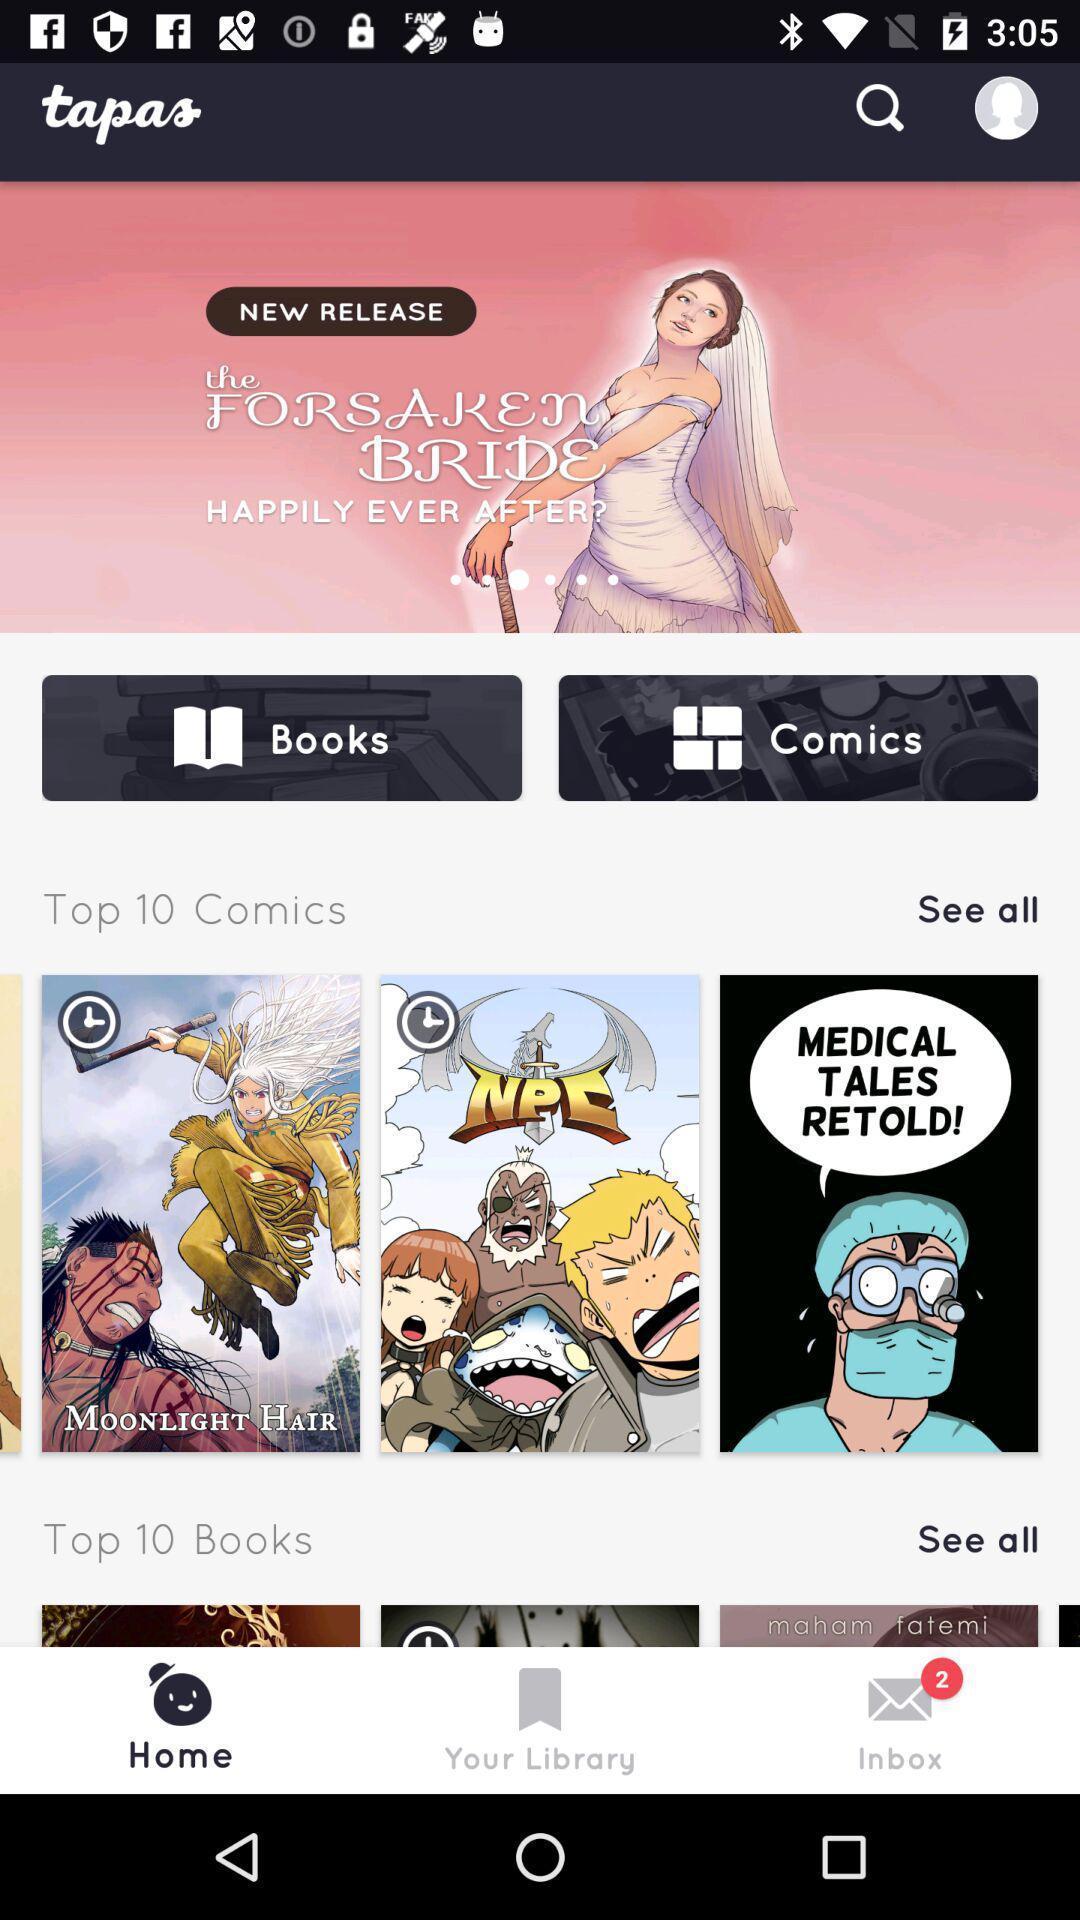Explain what's happening in this screen capture. Screening displaying the multiple books and comics. 